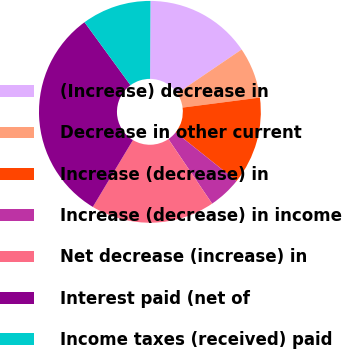<chart> <loc_0><loc_0><loc_500><loc_500><pie_chart><fcel>(Increase) decrease in<fcel>Decrease in other current<fcel>Increase (decrease) in<fcel>Increase (decrease) in income<fcel>Net decrease (increase) in<fcel>Interest paid (net of<fcel>Income taxes (received) paid<nl><fcel>15.42%<fcel>7.45%<fcel>12.77%<fcel>4.8%<fcel>18.08%<fcel>31.37%<fcel>10.11%<nl></chart> 